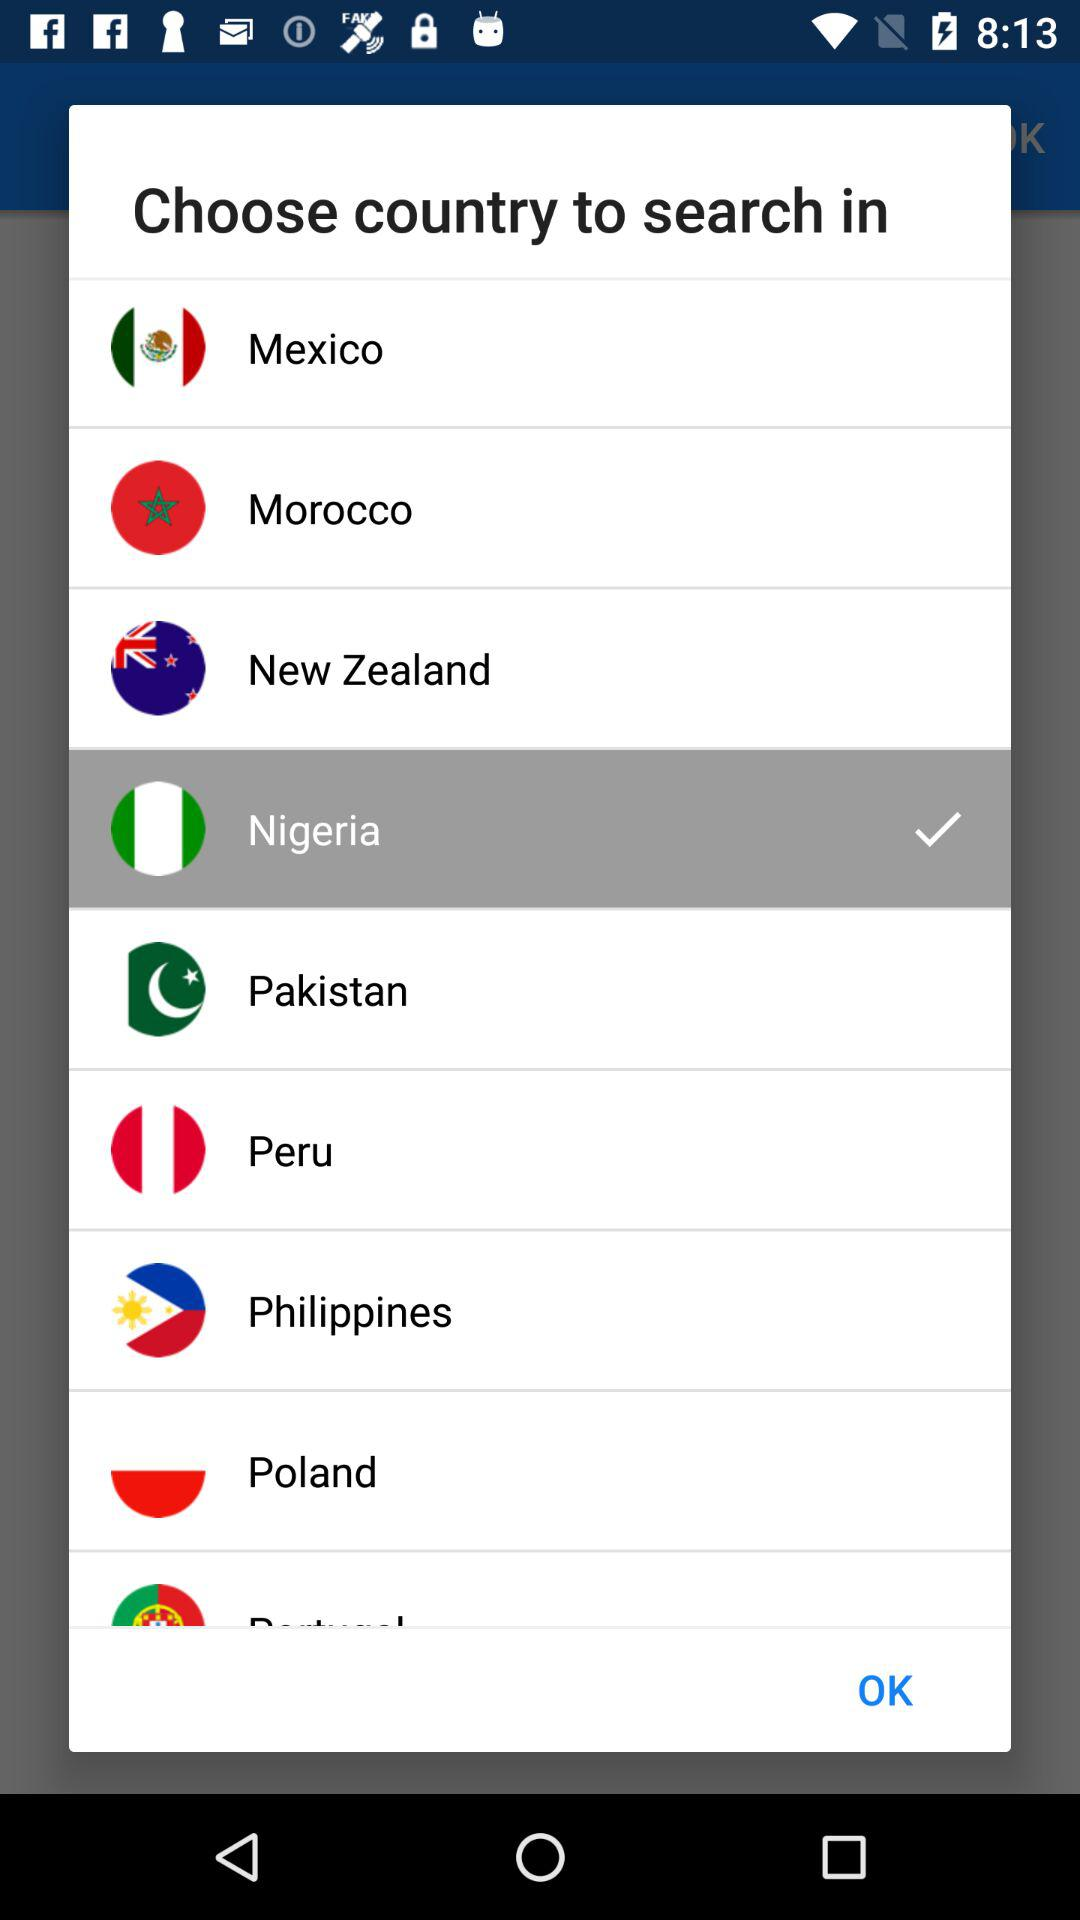Which country is selected? The selected country is Nigeria. 